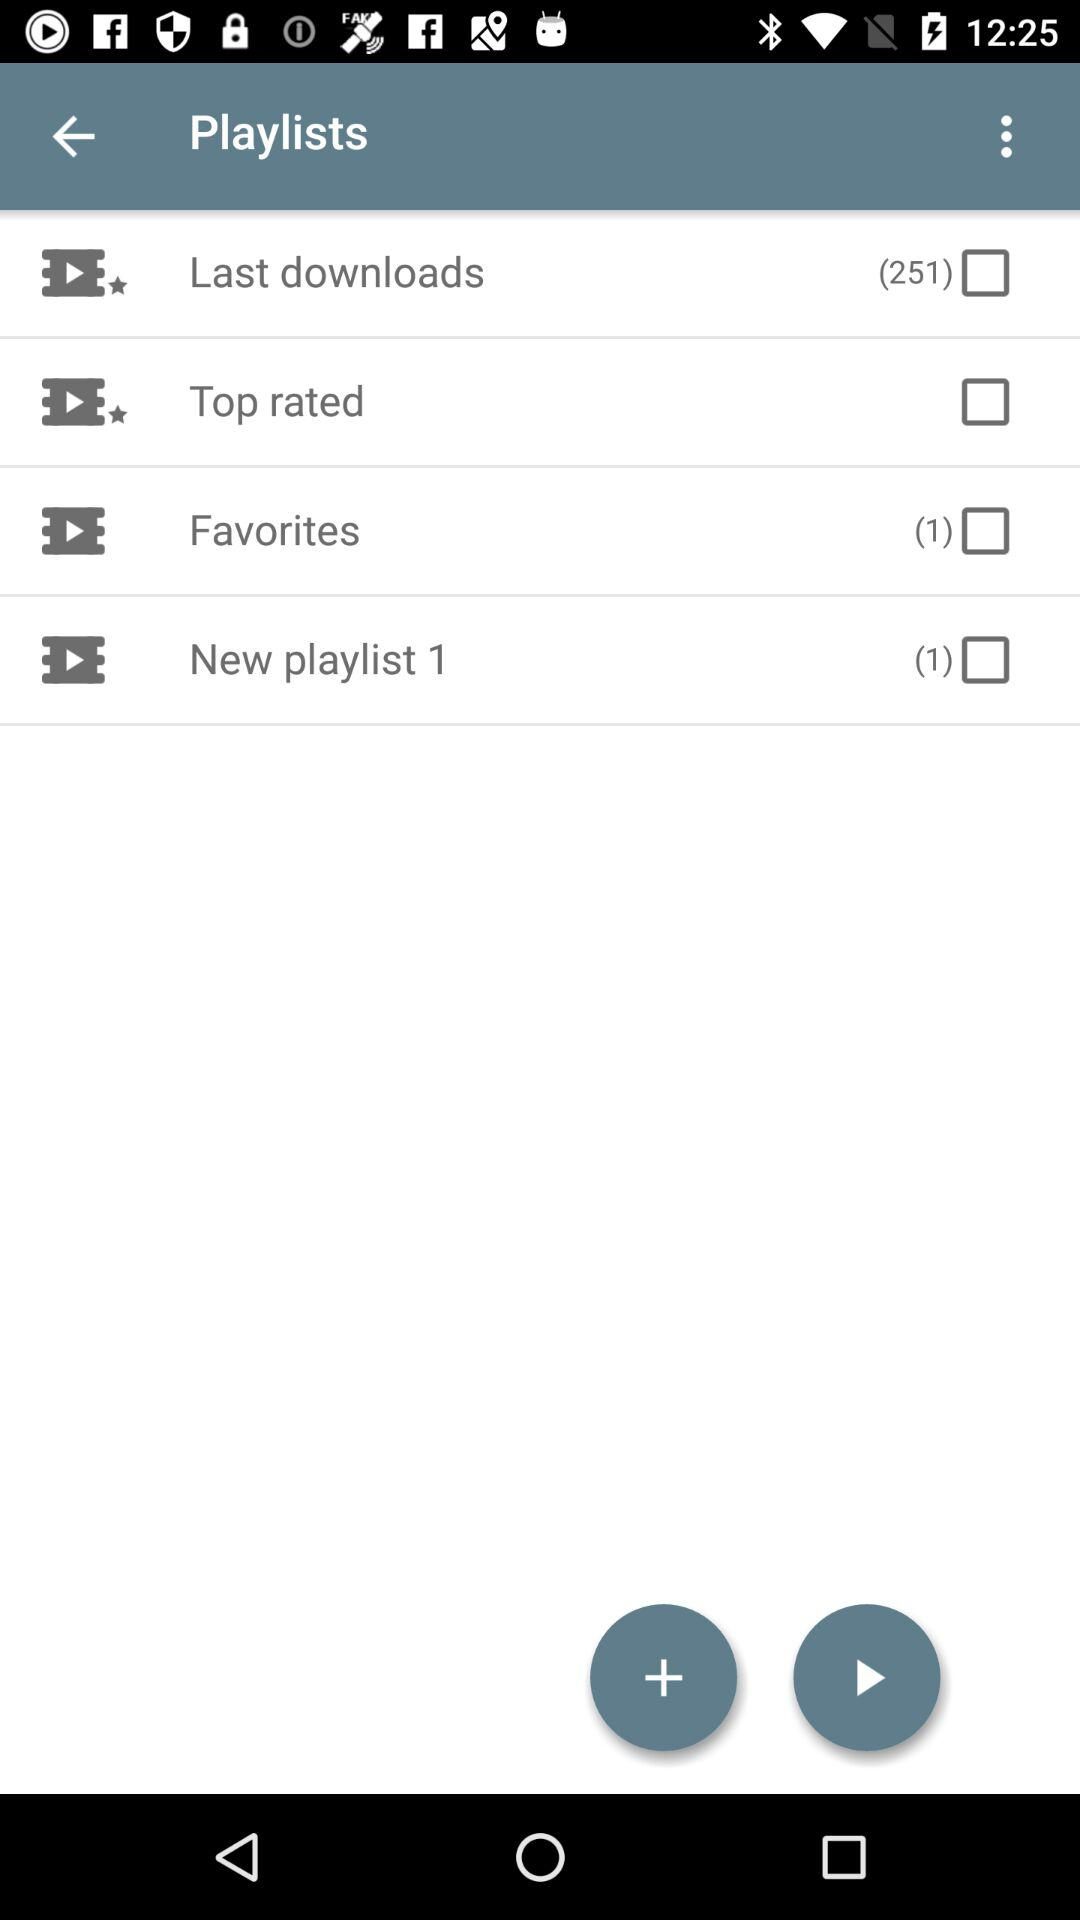How many songs in total are there in "New playlist 1"? There is 1 song in "New playlist 1". 